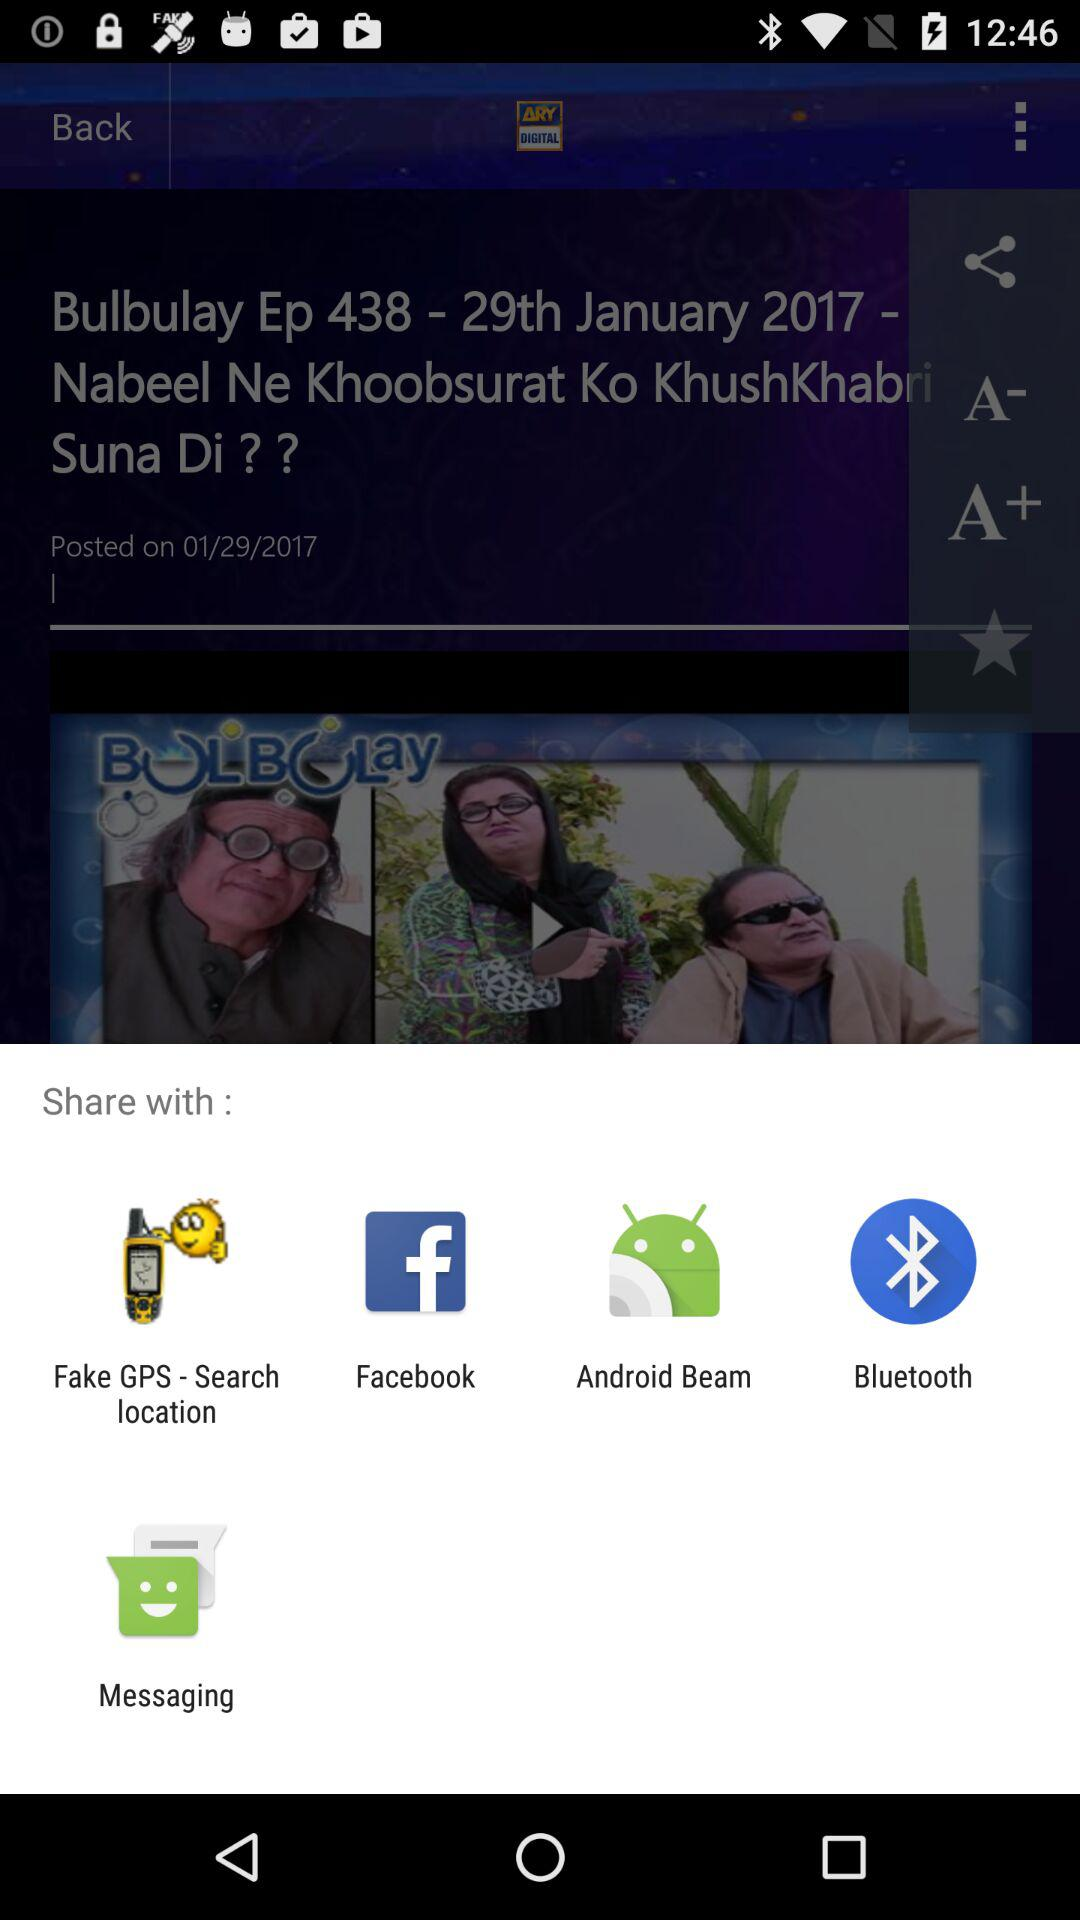What are the sharing options? The sharing options are "Fake GPS - Search location", "Facebook", "Android Beam", "Bluetooth" and "Messaging". 